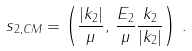<formula> <loc_0><loc_0><loc_500><loc_500>s _ { 2 , C M } = \left ( \frac { | { k _ { 2 } } | } { \mu } , \, \frac { E _ { 2 } } { \mu } \frac { k _ { 2 } } { | { k _ { 2 } } | } \right ) \, .</formula> 